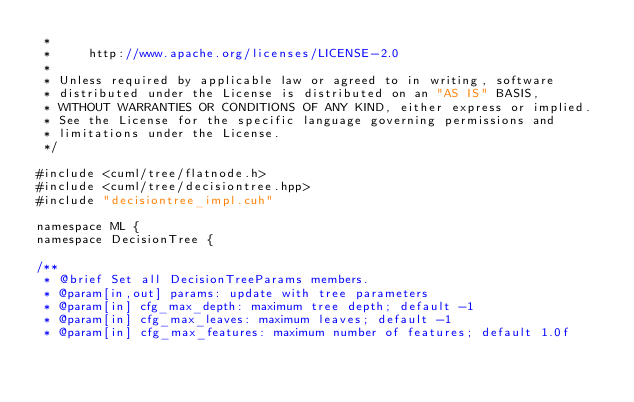Convert code to text. <code><loc_0><loc_0><loc_500><loc_500><_Cuda_> *
 *     http://www.apache.org/licenses/LICENSE-2.0
 *
 * Unless required by applicable law or agreed to in writing, software
 * distributed under the License is distributed on an "AS IS" BASIS,
 * WITHOUT WARRANTIES OR CONDITIONS OF ANY KIND, either express or implied.
 * See the License for the specific language governing permissions and
 * limitations under the License.
 */

#include <cuml/tree/flatnode.h>
#include <cuml/tree/decisiontree.hpp>
#include "decisiontree_impl.cuh"

namespace ML {
namespace DecisionTree {

/**
 * @brief Set all DecisionTreeParams members.
 * @param[in,out] params: update with tree parameters
 * @param[in] cfg_max_depth: maximum tree depth; default -1
 * @param[in] cfg_max_leaves: maximum leaves; default -1
 * @param[in] cfg_max_features: maximum number of features; default 1.0f</code> 